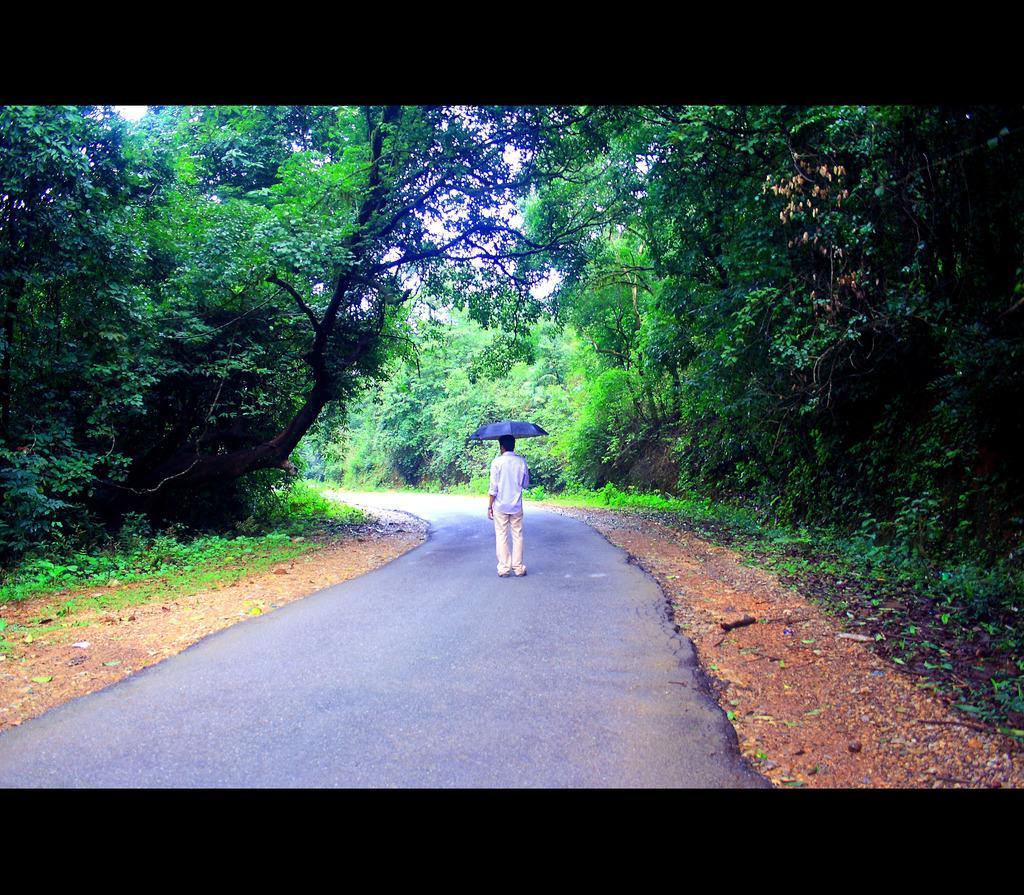Can you describe this image briefly? In this image there is a person standing on the road. He is holding an umbrella. Background there are few plants and trees. Behind there is sky. 